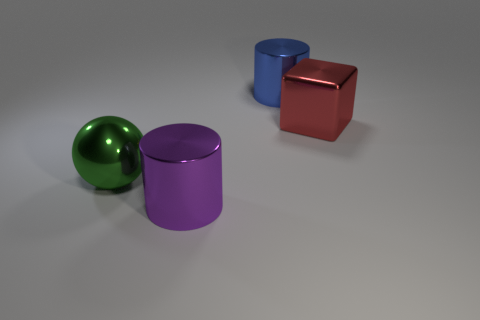Add 1 balls. How many objects exist? 5 Subtract all blocks. How many objects are left? 3 Subtract 0 yellow cylinders. How many objects are left? 4 Subtract all big red metal objects. Subtract all green shiny balls. How many objects are left? 2 Add 2 big spheres. How many big spheres are left? 3 Add 4 big balls. How many big balls exist? 5 